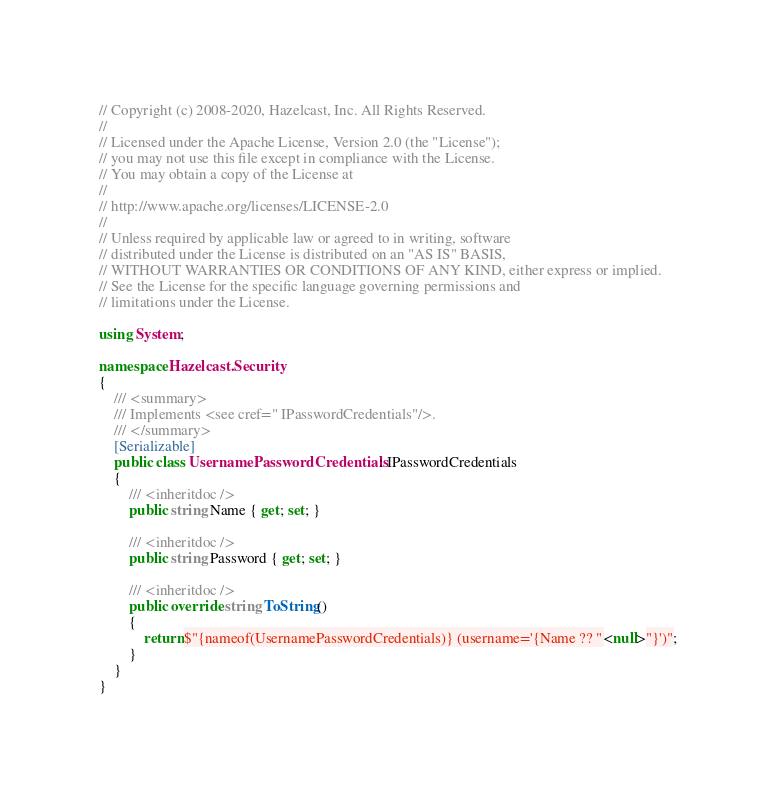<code> <loc_0><loc_0><loc_500><loc_500><_C#_>// Copyright (c) 2008-2020, Hazelcast, Inc. All Rights Reserved.
//
// Licensed under the Apache License, Version 2.0 (the "License");
// you may not use this file except in compliance with the License.
// You may obtain a copy of the License at
//
// http://www.apache.org/licenses/LICENSE-2.0
//
// Unless required by applicable law or agreed to in writing, software
// distributed under the License is distributed on an "AS IS" BASIS,
// WITHOUT WARRANTIES OR CONDITIONS OF ANY KIND, either express or implied.
// See the License for the specific language governing permissions and
// limitations under the License.

using System;

namespace Hazelcast.Security
{
    /// <summary>
    /// Implements <see cref=" IPasswordCredentials"/>.
    /// </summary>
    [Serializable]
    public class UsernamePasswordCredentials : IPasswordCredentials
    {
        /// <inheritdoc />
        public string Name { get; set; }

        /// <inheritdoc />
        public string Password { get; set; }

        /// <inheritdoc />
        public override string ToString()
        {
            return $"{nameof(UsernamePasswordCredentials)} (username='{Name ?? "<null>"}')";
        }
    }
}</code> 